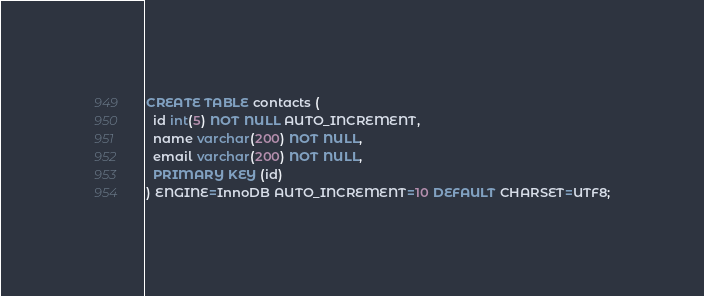Convert code to text. <code><loc_0><loc_0><loc_500><loc_500><_SQL_>CREATE TABLE contacts (
  id int(5) NOT NULL AUTO_INCREMENT,
  name varchar(200) NOT NULL,
  email varchar(200) NOT NULL,
  PRIMARY KEY (id)
) ENGINE=InnoDB AUTO_INCREMENT=10 DEFAULT CHARSET=UTF8;
</code> 